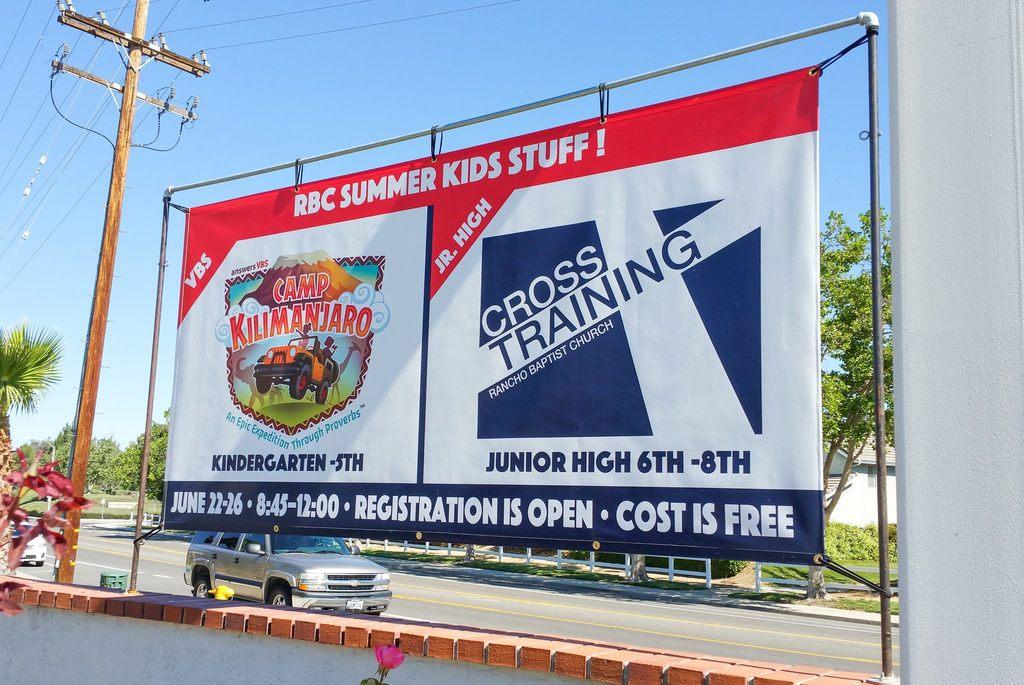Provide a one-sentence caption for the provided image. The poster near the powerlines displays summer activities for children in the local community. 